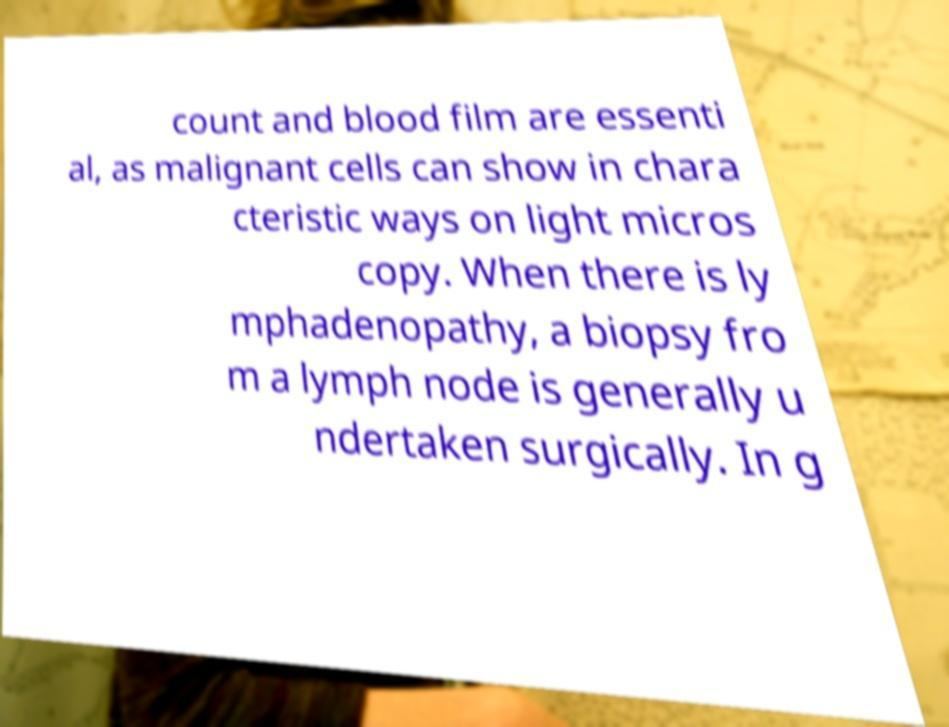There's text embedded in this image that I need extracted. Can you transcribe it verbatim? count and blood film are essenti al, as malignant cells can show in chara cteristic ways on light micros copy. When there is ly mphadenopathy, a biopsy fro m a lymph node is generally u ndertaken surgically. In g 